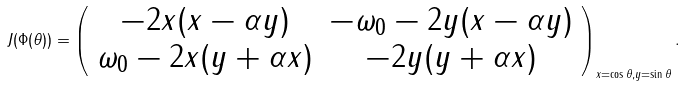Convert formula to latex. <formula><loc_0><loc_0><loc_500><loc_500>J ( \Phi ( \theta ) ) = \left ( \begin{array} { c c } - 2 x ( x - \alpha y ) & - \omega _ { 0 } - 2 y ( x - \alpha y ) \\ \omega _ { 0 } - 2 x ( y + \alpha x ) & - 2 y ( y + \alpha x ) \end{array} \right ) _ { x = \cos \theta , y = \sin \theta } .</formula> 